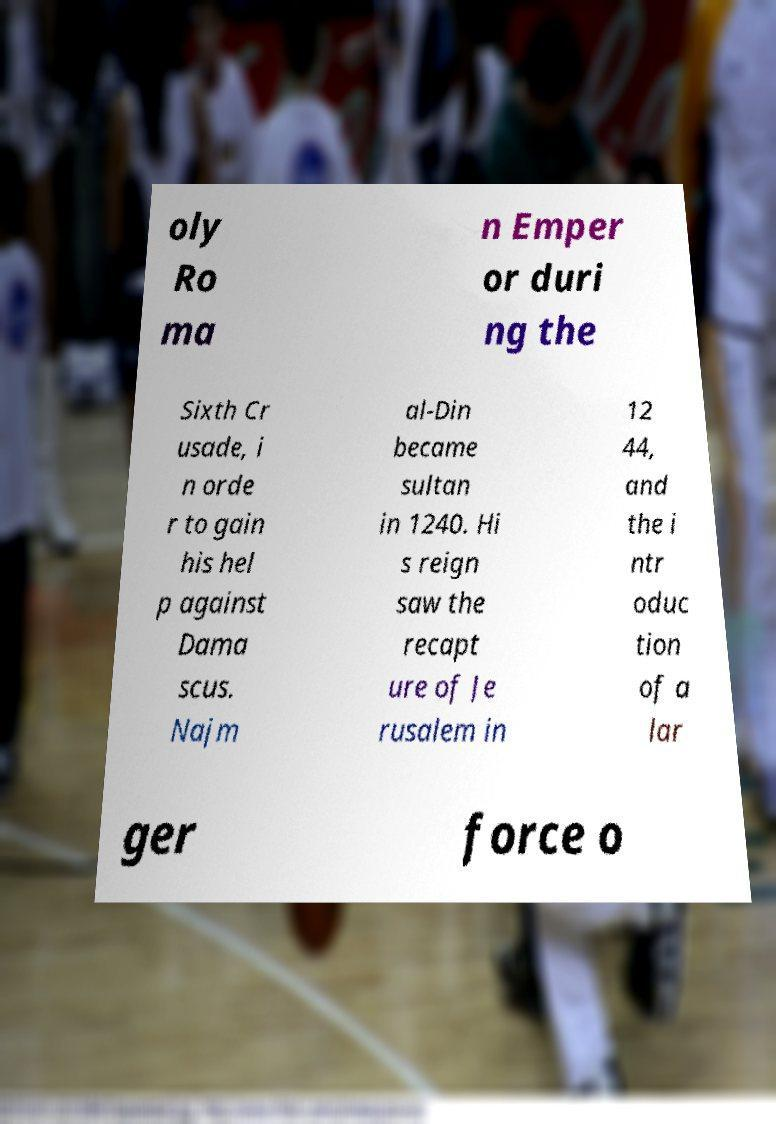Could you assist in decoding the text presented in this image and type it out clearly? oly Ro ma n Emper or duri ng the Sixth Cr usade, i n orde r to gain his hel p against Dama scus. Najm al-Din became sultan in 1240. Hi s reign saw the recapt ure of Je rusalem in 12 44, and the i ntr oduc tion of a lar ger force o 